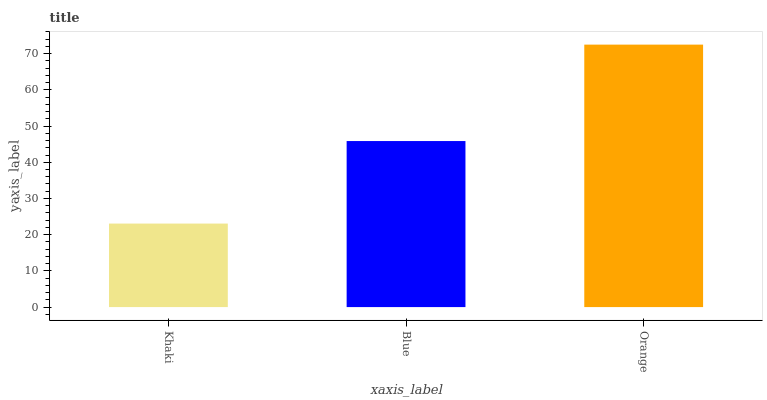Is Khaki the minimum?
Answer yes or no. Yes. Is Orange the maximum?
Answer yes or no. Yes. Is Blue the minimum?
Answer yes or no. No. Is Blue the maximum?
Answer yes or no. No. Is Blue greater than Khaki?
Answer yes or no. Yes. Is Khaki less than Blue?
Answer yes or no. Yes. Is Khaki greater than Blue?
Answer yes or no. No. Is Blue less than Khaki?
Answer yes or no. No. Is Blue the high median?
Answer yes or no. Yes. Is Blue the low median?
Answer yes or no. Yes. Is Khaki the high median?
Answer yes or no. No. Is Orange the low median?
Answer yes or no. No. 